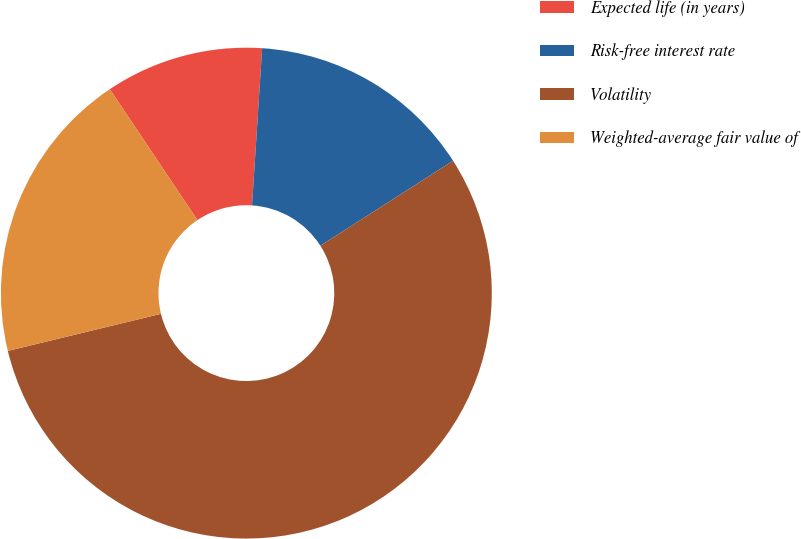Convert chart to OTSL. <chart><loc_0><loc_0><loc_500><loc_500><pie_chart><fcel>Expected life (in years)<fcel>Risk-free interest rate<fcel>Volatility<fcel>Weighted-average fair value of<nl><fcel>10.42%<fcel>14.91%<fcel>55.28%<fcel>19.39%<nl></chart> 